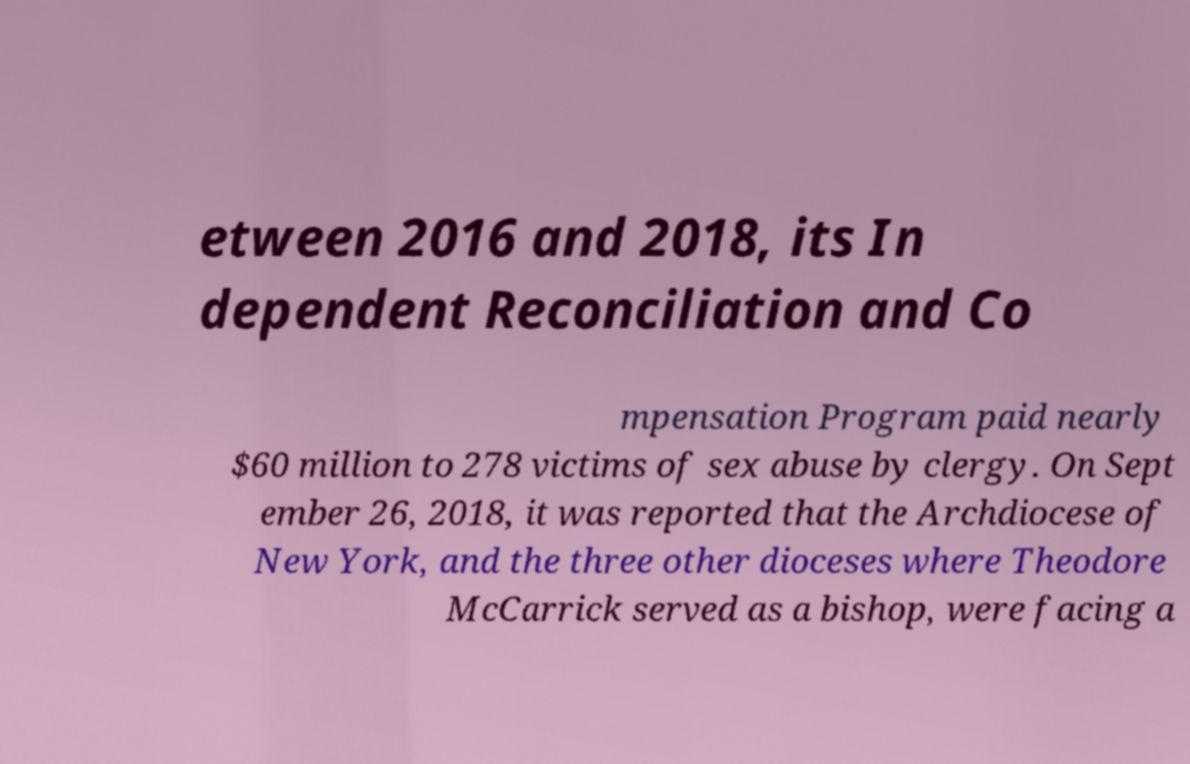For documentation purposes, I need the text within this image transcribed. Could you provide that? etween 2016 and 2018, its In dependent Reconciliation and Co mpensation Program paid nearly $60 million to 278 victims of sex abuse by clergy. On Sept ember 26, 2018, it was reported that the Archdiocese of New York, and the three other dioceses where Theodore McCarrick served as a bishop, were facing a 